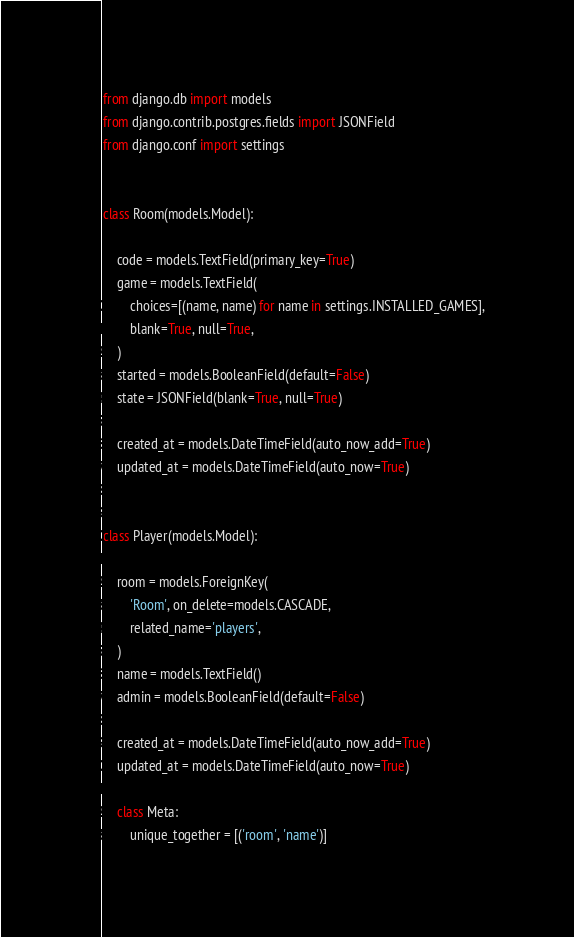<code> <loc_0><loc_0><loc_500><loc_500><_Python_>from django.db import models
from django.contrib.postgres.fields import JSONField
from django.conf import settings


class Room(models.Model):

    code = models.TextField(primary_key=True)
    game = models.TextField(
        choices=[(name, name) for name in settings.INSTALLED_GAMES],
        blank=True, null=True,
    )
    started = models.BooleanField(default=False)
    state = JSONField(blank=True, null=True)

    created_at = models.DateTimeField(auto_now_add=True)
    updated_at = models.DateTimeField(auto_now=True)


class Player(models.Model):

    room = models.ForeignKey(
        'Room', on_delete=models.CASCADE,
        related_name='players',
    )
    name = models.TextField()
    admin = models.BooleanField(default=False)

    created_at = models.DateTimeField(auto_now_add=True)
    updated_at = models.DateTimeField(auto_now=True)

    class Meta:
        unique_together = [('room', 'name')]
</code> 